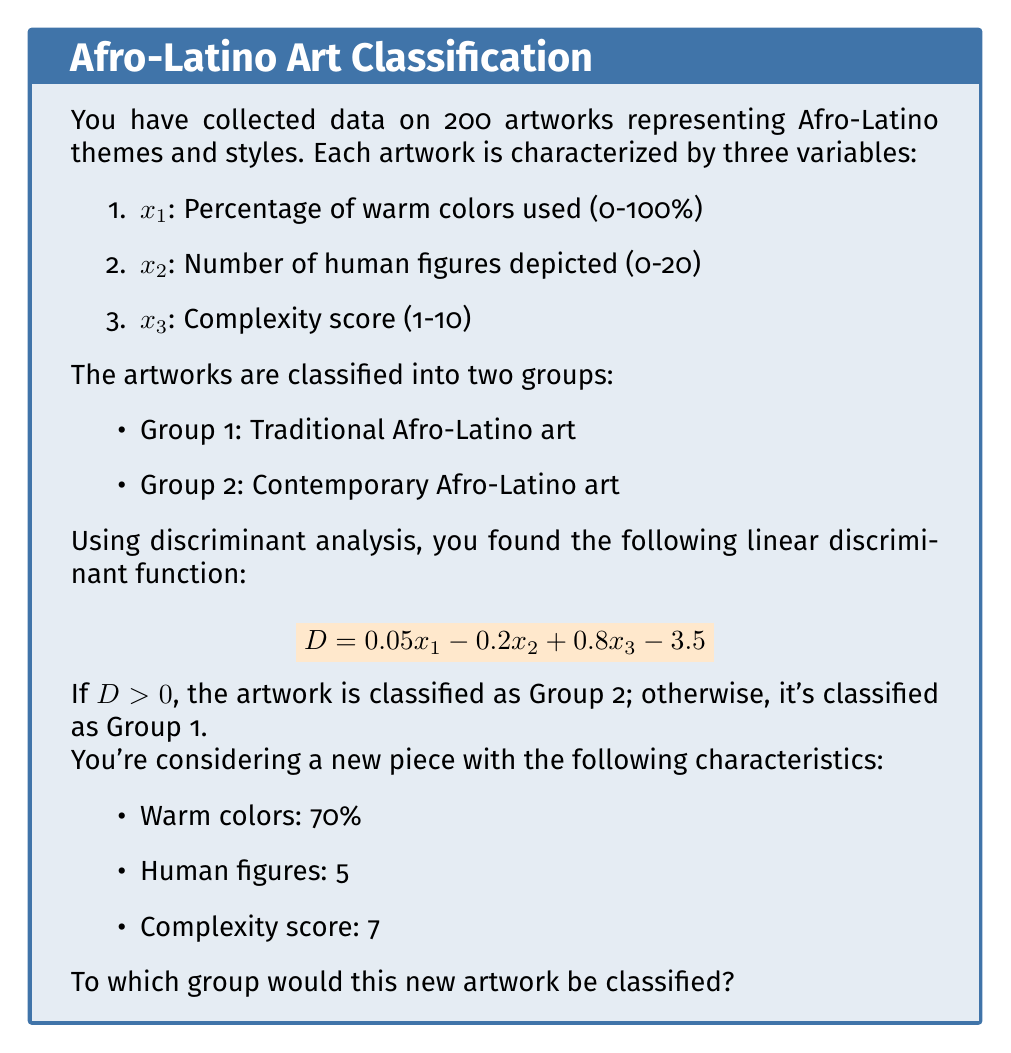Can you answer this question? To determine the classification of the new artwork, we need to follow these steps:

1. Identify the values for each variable:
   $x_1 = 70$ (percentage of warm colors)
   $x_2 = 5$ (number of human figures)
   $x_3 = 7$ (complexity score)

2. Substitute these values into the linear discriminant function:
   $$D = 0.05x_1 - 0.2x_2 + 0.8x_3 - 3.5$$

3. Calculate D:
   $$\begin{aligned}
   D &= 0.05(70) - 0.2(5) + 0.8(7) - 3.5 \\
   &= 3.5 - 1 + 5.6 - 3.5 \\
   &= 4.6
   \end{aligned}$$

4. Interpret the result:
   Since $D = 4.6 > 0$, the artwork is classified as Group 2.

Therefore, this new artwork would be classified as Contemporary Afro-Latino art (Group 2).
Answer: Group 2 (Contemporary Afro-Latino art) 